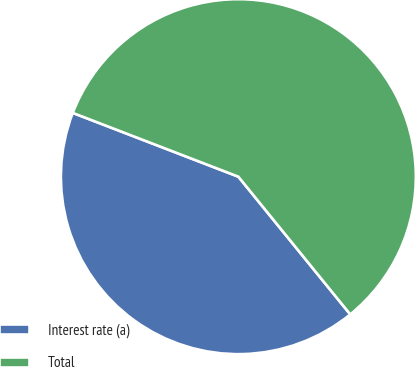Convert chart. <chart><loc_0><loc_0><loc_500><loc_500><pie_chart><fcel>Interest rate (a)<fcel>Total<nl><fcel>41.71%<fcel>58.29%<nl></chart> 